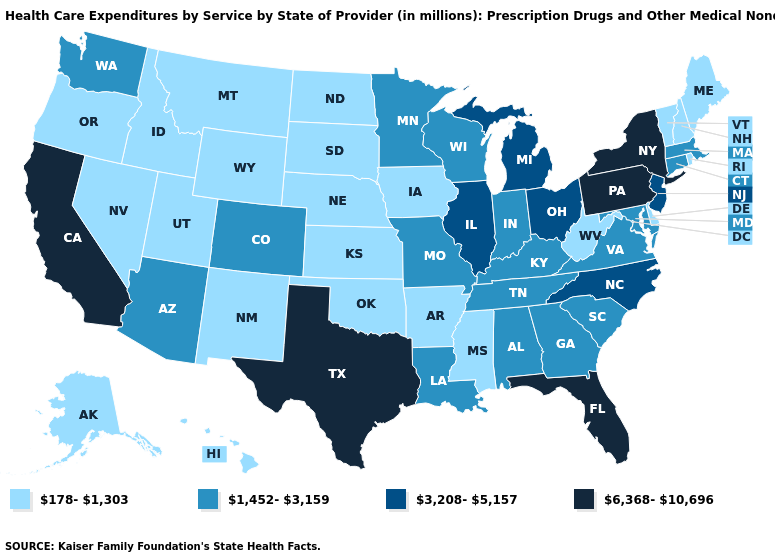Does Arizona have a higher value than South Carolina?
Answer briefly. No. Name the states that have a value in the range 3,208-5,157?
Short answer required. Illinois, Michigan, New Jersey, North Carolina, Ohio. Which states have the highest value in the USA?
Give a very brief answer. California, Florida, New York, Pennsylvania, Texas. What is the value of Kentucky?
Short answer required. 1,452-3,159. Is the legend a continuous bar?
Be succinct. No. Does South Carolina have the same value as Virginia?
Give a very brief answer. Yes. How many symbols are there in the legend?
Quick response, please. 4. Does Missouri have the highest value in the MidWest?
Quick response, please. No. What is the highest value in states that border Texas?
Answer briefly. 1,452-3,159. Which states have the lowest value in the USA?
Short answer required. Alaska, Arkansas, Delaware, Hawaii, Idaho, Iowa, Kansas, Maine, Mississippi, Montana, Nebraska, Nevada, New Hampshire, New Mexico, North Dakota, Oklahoma, Oregon, Rhode Island, South Dakota, Utah, Vermont, West Virginia, Wyoming. What is the value of Colorado?
Write a very short answer. 1,452-3,159. Does Pennsylvania have the highest value in the Northeast?
Write a very short answer. Yes. Does the first symbol in the legend represent the smallest category?
Answer briefly. Yes. Which states have the lowest value in the USA?
Give a very brief answer. Alaska, Arkansas, Delaware, Hawaii, Idaho, Iowa, Kansas, Maine, Mississippi, Montana, Nebraska, Nevada, New Hampshire, New Mexico, North Dakota, Oklahoma, Oregon, Rhode Island, South Dakota, Utah, Vermont, West Virginia, Wyoming. Does Rhode Island have a higher value than Mississippi?
Write a very short answer. No. 